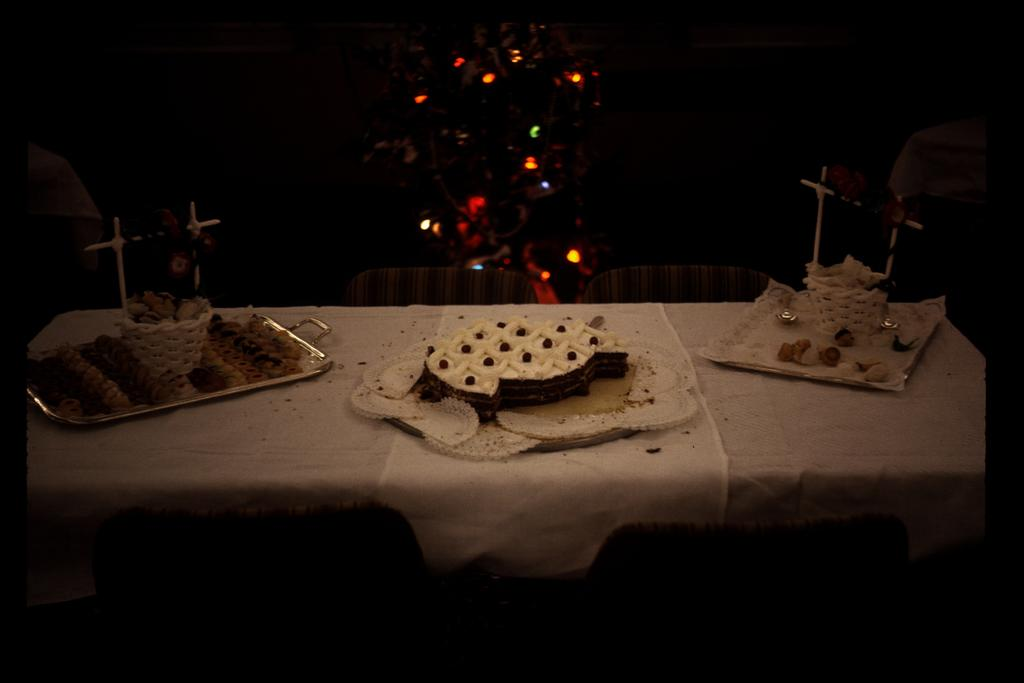What is the main food item on the table in the image? There is a cake on the table in the image. What else can be seen on the table besides the cake? There are food items in plates in the image. What can be seen in the image that provides illumination? There are lightings visible in the image. How would you describe the lighting in the image? The image appears to be darker in the background. What degree does the base of the cake have in the image? There is no mention of a degree or base of the cake in the image. The image only shows a cake on the table with food items in plates. 